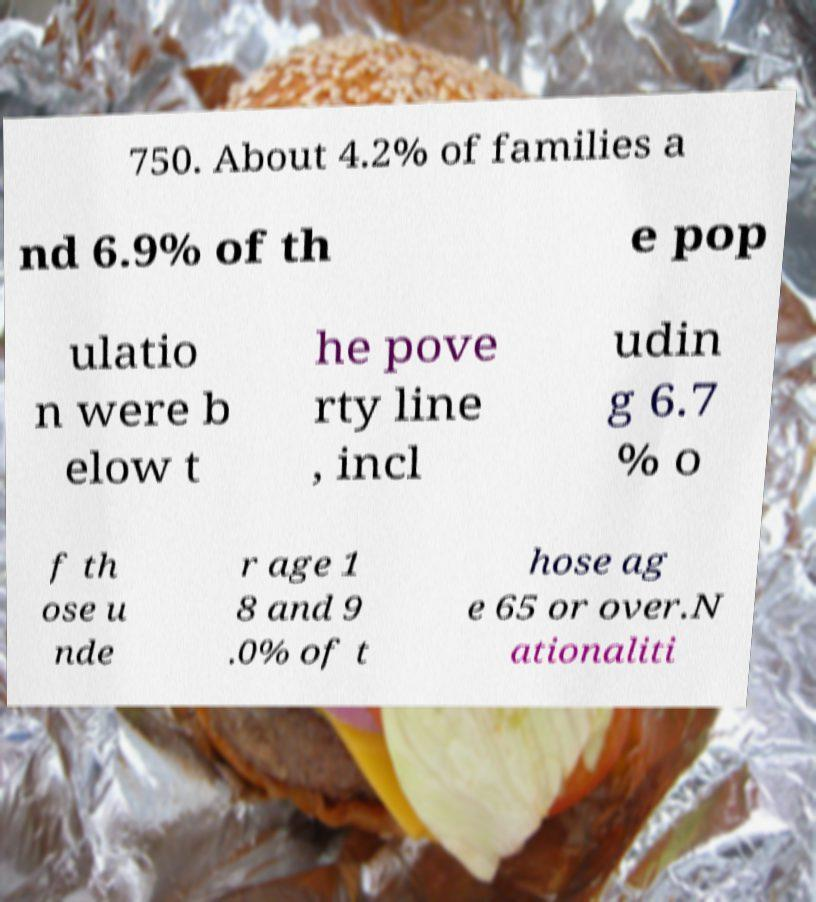Please identify and transcribe the text found in this image. 750. About 4.2% of families a nd 6.9% of th e pop ulatio n were b elow t he pove rty line , incl udin g 6.7 % o f th ose u nde r age 1 8 and 9 .0% of t hose ag e 65 or over.N ationaliti 